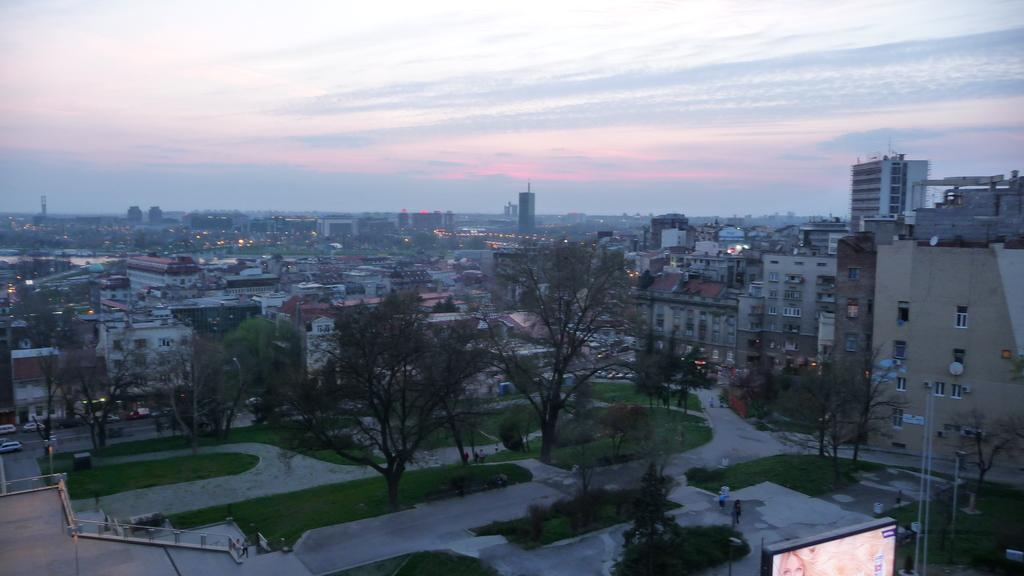What is the main subject of the image? The main subject of the image is an overview of a city. What can be seen in the image besides the cityscape? There are many buildings, trees, plants, a road, and the sky visible in the image. What is the color of the sky in the image? The sky is white in color in the image. Are there any weather conditions depicted in the image? Yes, there are clouds in the sky, which suggests a partly cloudy condition. How does the steam from the chimneys contribute to the death of the trees in the image? There are no chimneys or steam present in the image, and therefore no such impact on the trees can be observed. 